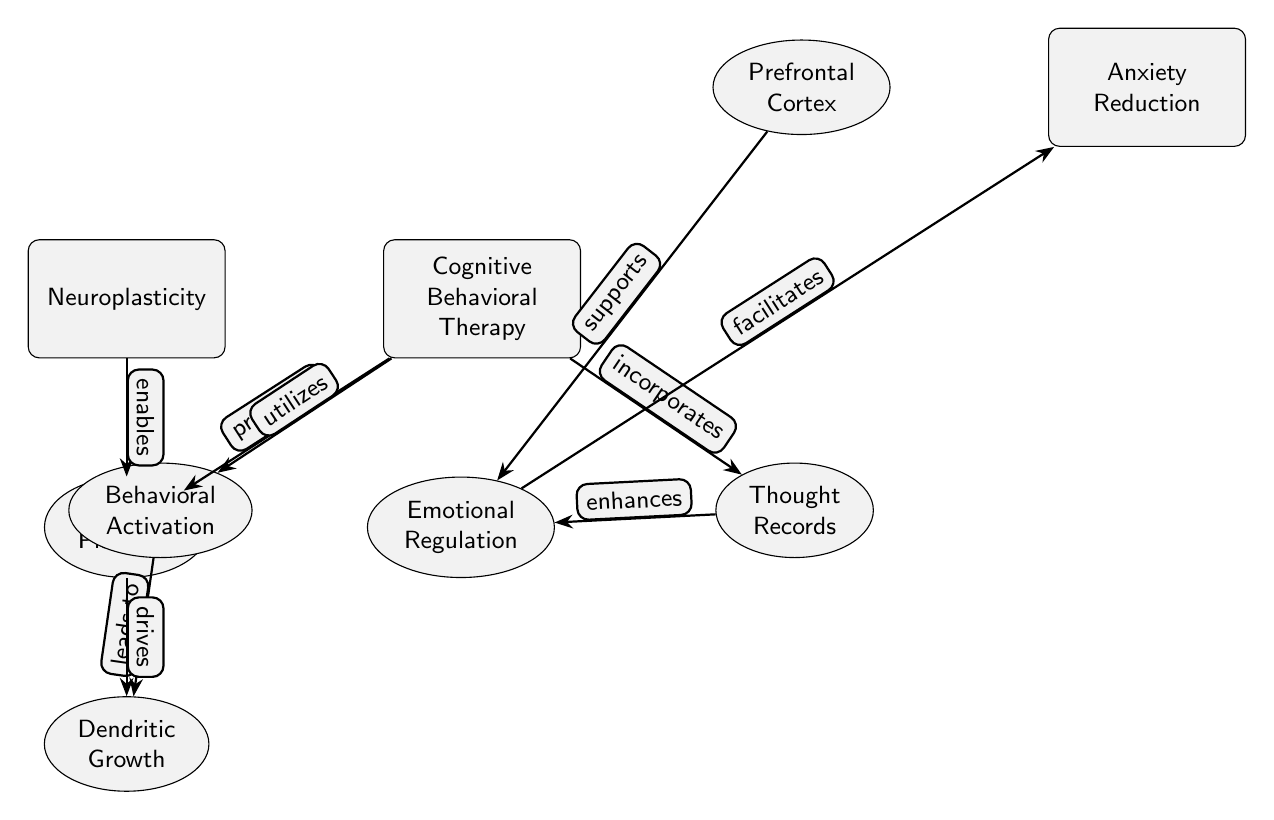What are the two main nodes in the diagram? The main nodes are displayed at the top level, representing the key concepts: Neuroplasticity and Cognitive Behavioral Therapy.
Answer: Neuroplasticity, Cognitive Behavioral Therapy What effect does Cognitive Behavioral Therapy have on Synaptic Plasticity? The diagram shows a directed edge from Cognitive Behavioral Therapy to Synaptic Plasticity labeled "promotes," indicating that the therapy positively influences the process of synaptic changes in the brain.
Answer: promotes How many sub-nodes are connected to Cognitive Behavioral Therapy? By inspecting the diagram, we see that there are two sub-nodes linked to Cognitive Behavioral Therapy: Behavioral Activation and Thought Records, making a total of two.
Answer: 2 What does Behavioral Activation lead to in the diagram? Following the edge from Behavioral Activation, the diagram indicates it leads to Dendritic Growth, showing a clear effect of this approach on enhancing neural structure.
Answer: Dendritic Growth Which node supports Emotional Regulation? The diagram displays an edge from the Prefrontal Cortex to Emotional Regulation, indicating that the Prefrontal Cortex is a supporting factor for emotional control processes.
Answer: Prefrontal Cortex How does Synaptic Plasticity interact with Neuroplasticity? The diagram illustrates that Neuroplasticity enables Synaptic Plasticity, establishing a foundational relationship between the general concept of brain adaptability and specific synaptic changes.
Answer: enables What is the final outcome of the interactions depicted in the diagram? The interactions culminate in Anxiety Reduction, which is linked to both Emotional Regulation (via a facilitating edge) and the combined effects of other nodes contributing to this outcome.
Answer: Anxiety Reduction Which sub-node enhances Emotional Regulation? The diagram clearly shows that Thought Records (connected to Cognitive Behavioral Therapy) enhance Emotional Regulation, illustrating how cognitive strategies impact emotional processing.
Answer: Thought Records What effect does Emotional Regulation have on Anxiety Reduction? The diagram illustrates a facilitating relationship from Emotional Regulation to Anxiety Reduction, which indicates that better emotional control directly leads to a reduction in anxiety.
Answer: facilitates 